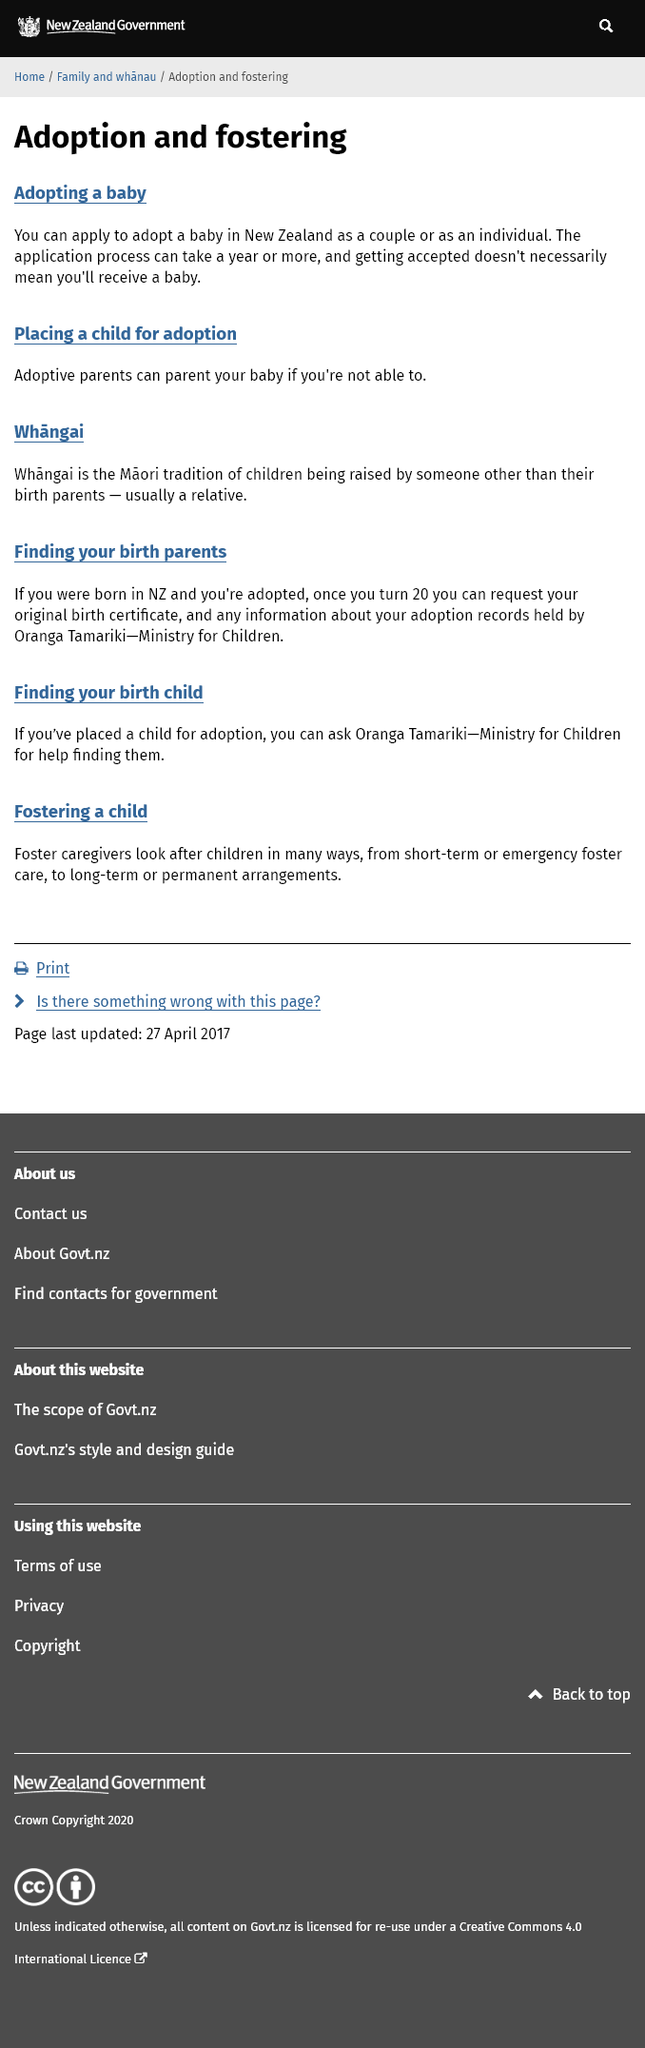List a handful of essential elements in this visual. If a person has placed a child for adoption and is seeking to find them, the Ministry for Children, also known as the orange tarariki, may be able to assist them in their search. You can adopt a baby in New Zealand whether you are in a couple or as an individual, as long as you meet the eligibility criteria and go through the required legal processes. The definition of whangai is a traditional practice in which children are raised by someone other than their biological parents. 